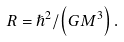<formula> <loc_0><loc_0><loc_500><loc_500>R = \hslash ^ { 2 } / \left ( G M ^ { 3 } \right ) .</formula> 